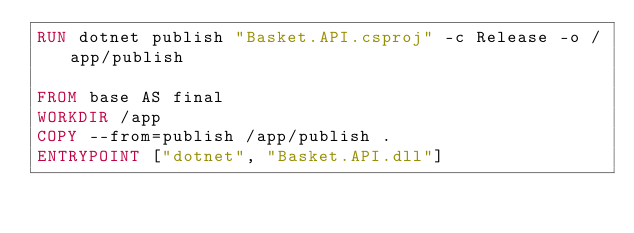<code> <loc_0><loc_0><loc_500><loc_500><_Dockerfile_>RUN dotnet publish "Basket.API.csproj" -c Release -o /app/publish

FROM base AS final
WORKDIR /app
COPY --from=publish /app/publish .
ENTRYPOINT ["dotnet", "Basket.API.dll"]</code> 